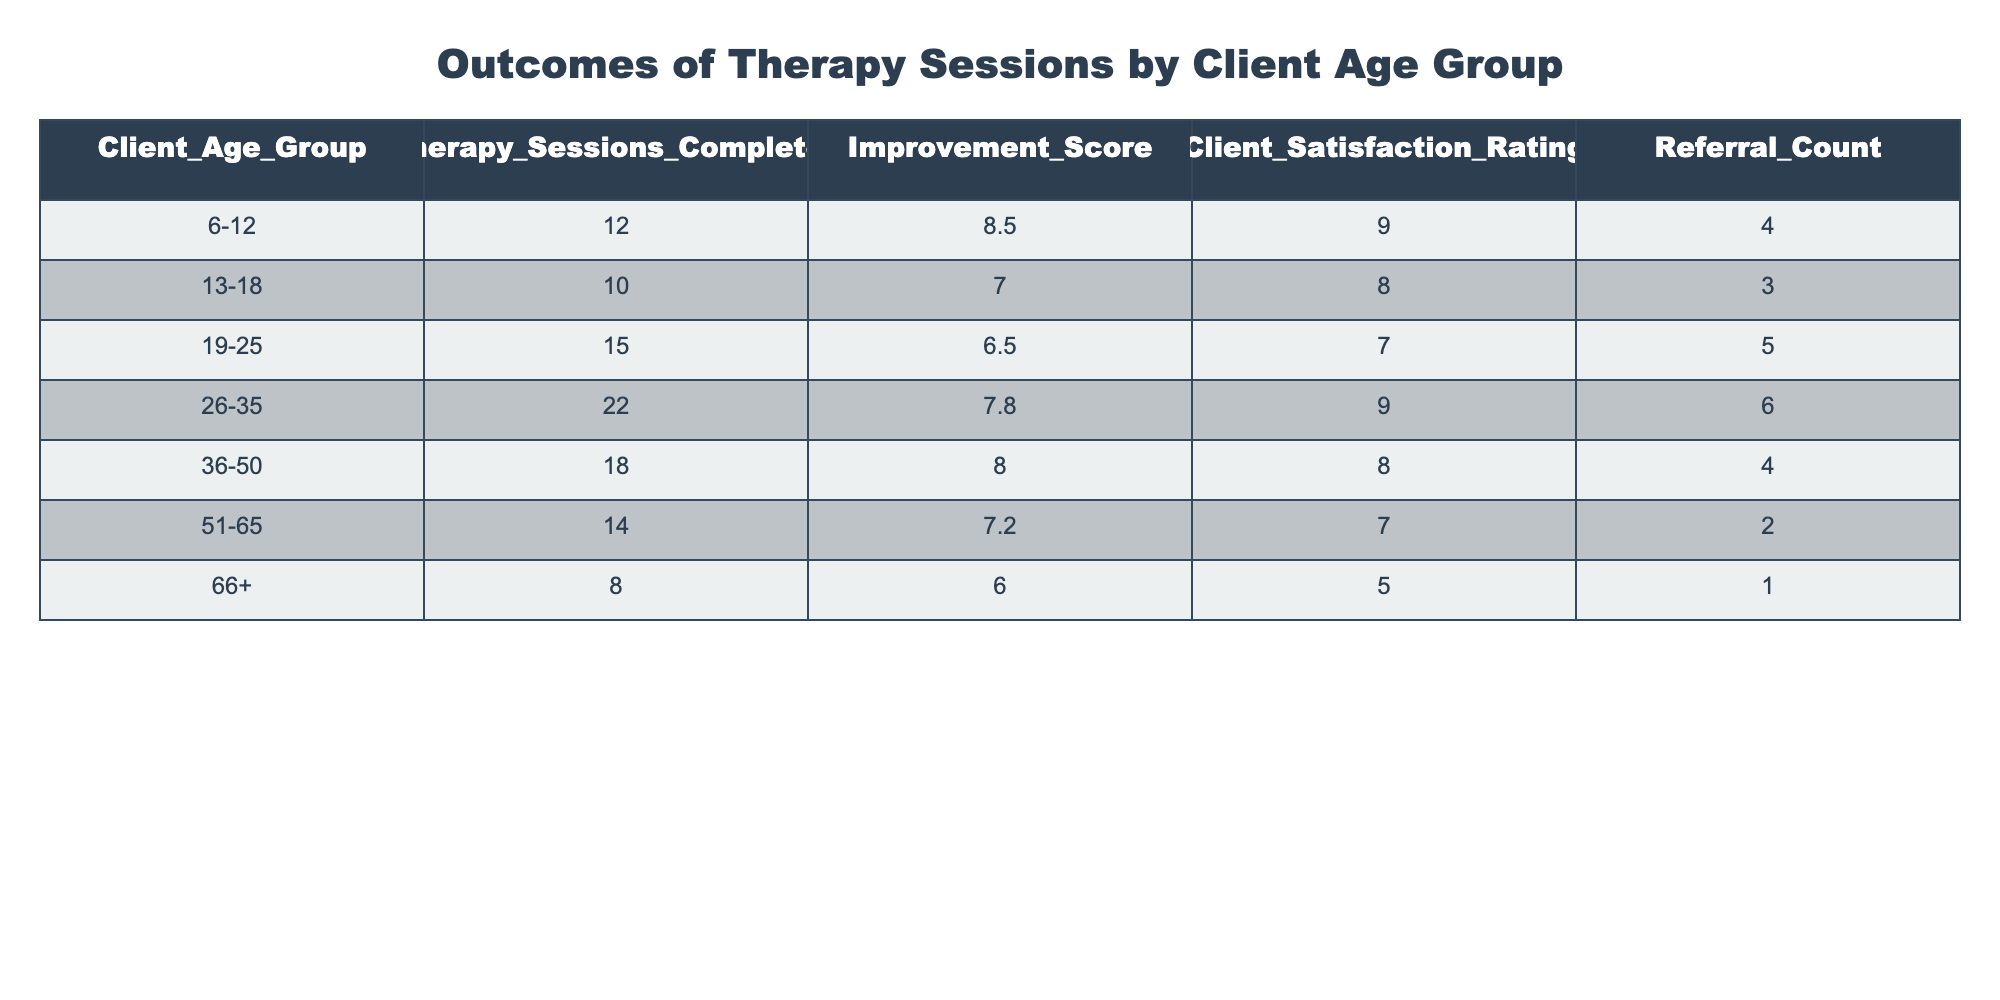What is the Improvement Score for the 26-35 age group? Looking at the table, the Improvement Score specifically listed for the 26-35 age group is 7.8
Answer: 7.8 How many therapy sessions did clients aged 51-65 complete? From the table, we can see that the number of therapy sessions completed by clients aged 51-65 is listed as 14
Answer: 14 Is the Client Satisfaction Rating for the 36-50 age group greater than 7? Checking the Client Satisfaction Rating for the 36-50 age group, which is 8, we confirm that it is indeed greater than 7
Answer: Yes What is the total number of therapy sessions completed by clients aged 6-12 and 13-18 combined? Summing the therapy sessions for these age groups: 12 (6-12) + 10 (13-18) = 22
Answer: 22 Which age group has the highest Referral Count? Upon examining the Referral Counts, the age group 26-35 has the highest count with 6 referrals, more than any other age group in the table
Answer: 26-35 What is the average Improvement Score across all age groups? Adding the Improvement Scores: 8.5 + 7.0 + 6.5 + 7.8 + 8.0 + 7.2 + 6.0 = 51.0. Since there are 7 age groups, we then divide by 7: 51.0 / 7 = 7.29
Answer: 7.29 Does the 66+ age group have a Client Satisfaction Rating of 6 or higher? Checking the Client Satisfaction Rating for the 66+ age group, which is 5, we see that it is not 6 or higher
Answer: No How many clients aged 19-25 achieved a higher Improvement Score than the average Improvement Score? The average Improvement Score, calculated earlier as 7.29, only the 26-35 age group has a higher Improvement Score of 7.8. Therefore, one client age group meets this condition.
Answer: 1 